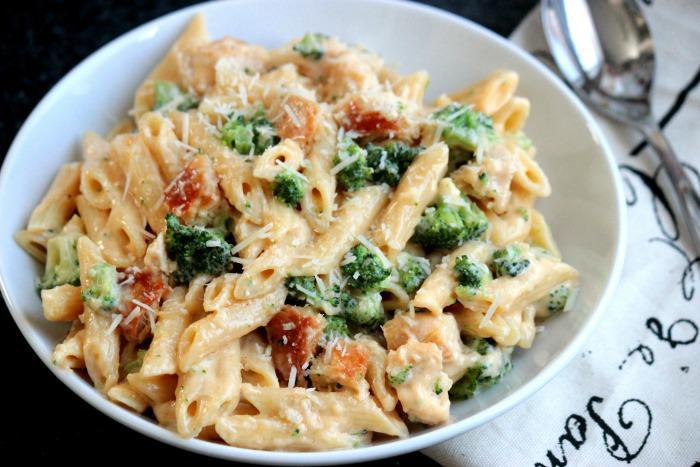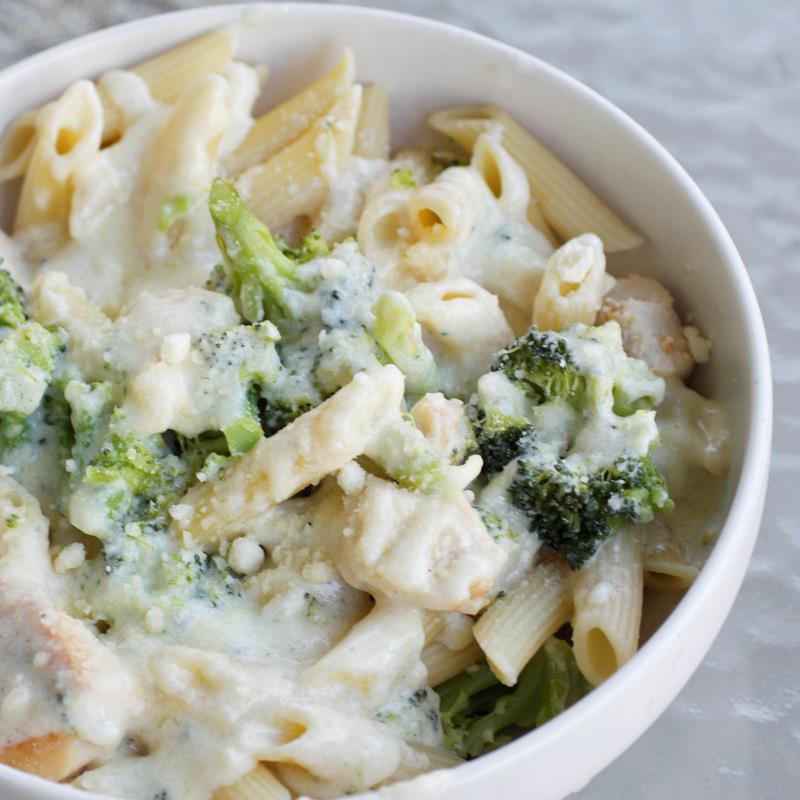The first image is the image on the left, the second image is the image on the right. Considering the images on both sides, is "At least one of the dishes doesn't have penne pasta." valid? Answer yes or no. No. 